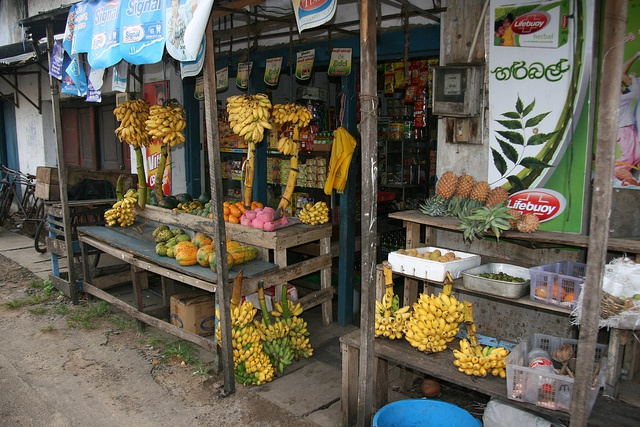Describe the objects in this image and their specific colors. I can see banana in black, olive, and maroon tones, banana in black, orange, gold, and olive tones, banana in black, tan, olive, and khaki tones, bicycle in black, gray, darkgray, and blue tones, and banana in black, orange, gold, olive, and tan tones in this image. 